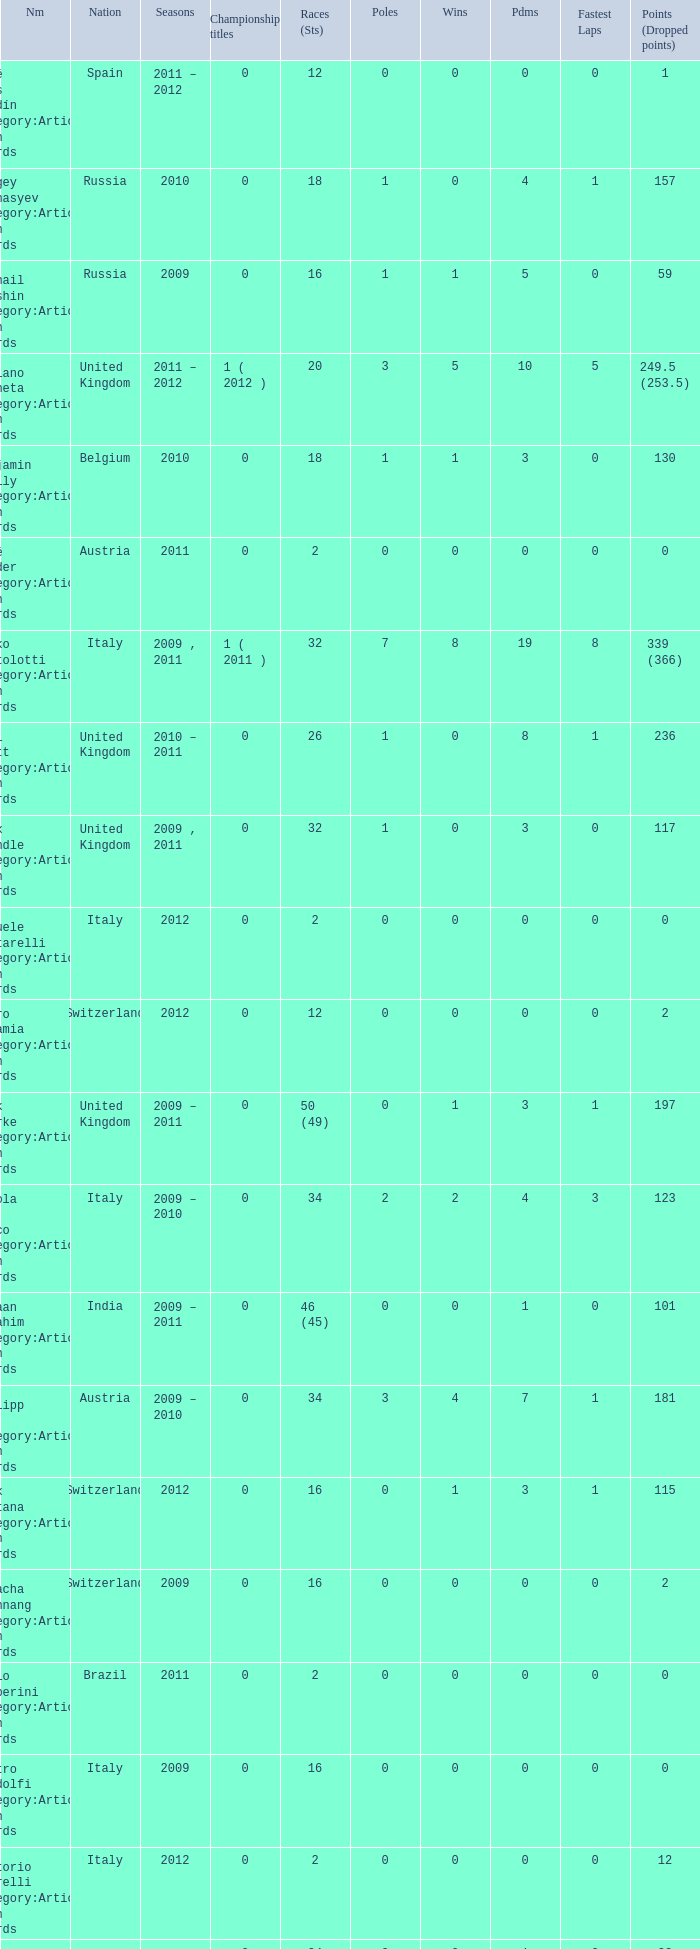What were the starts when the points dropped 18? 8.0. 